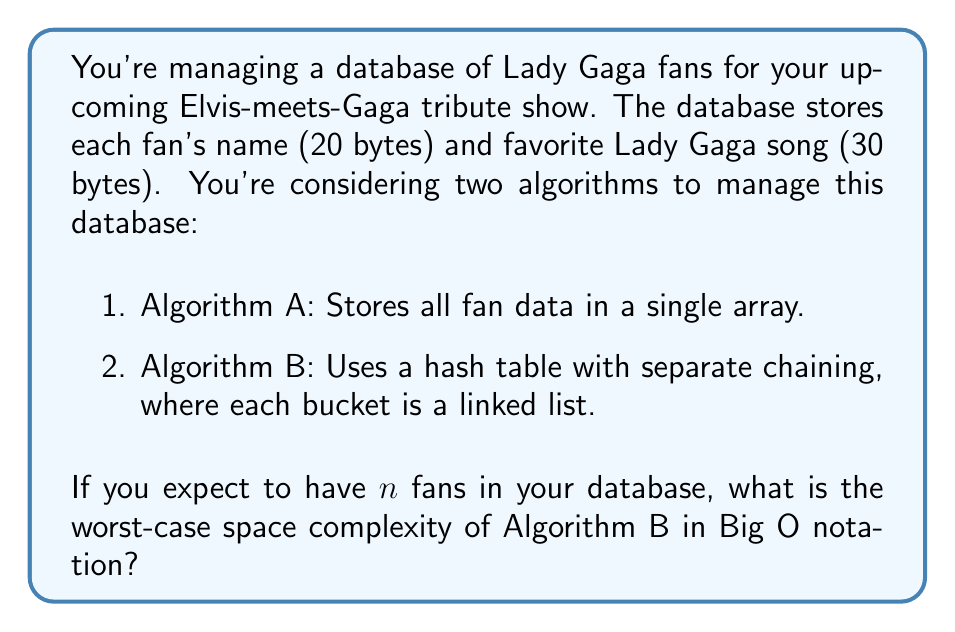Can you solve this math problem? Let's break this down step-by-step:

1. First, let's consider the space needed for each fan's data:
   - Name: 20 bytes
   - Favorite song: 30 bytes
   - Total: 50 bytes per fan

2. In a hash table with separate chaining, we need to consider:
   a) The array of buckets
   b) The linked list nodes

3. For the array of buckets:
   - The size of the array is typically chosen to be proportional to the number of elements, often $n$.
   - Each bucket contains a pointer to the head of its linked list, which typically requires 8 bytes on a 64-bit system.
   - So, the space for the array is $O(n)$ bytes.

4. For the linked list nodes:
   - Each node contains:
     * The fan data (50 bytes)
     * A pointer to the next node (8 bytes)
   - So, each node requires 58 bytes.
   - In the worst case, all $n$ fans could hash to the same bucket, creating a single linked list of length $n$.

5. Putting it all together:
   - Array space: $O(n)$
   - Linked list space: $58n$ bytes, which is $O(n)$

6. The total space is the sum of these components: $O(n) + O(n) = O(n)$

Therefore, the worst-case space complexity of Algorithm B is $O(n)$.
Answer: $O(n)$ 